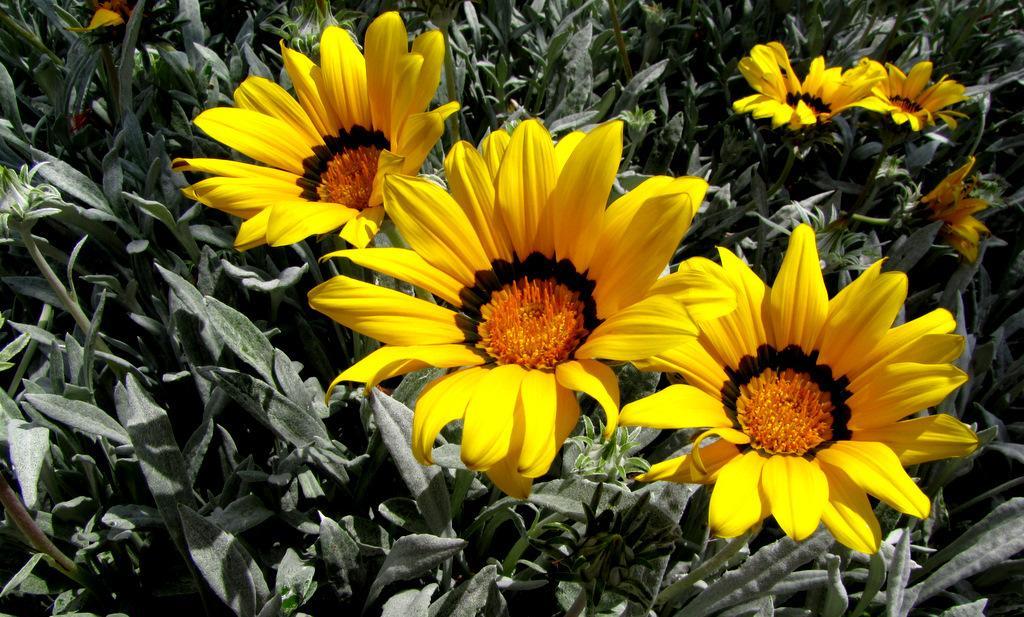Describe this image in one or two sentences. In this image I can see the yellow color flowers. In the background, I can see some plants. 